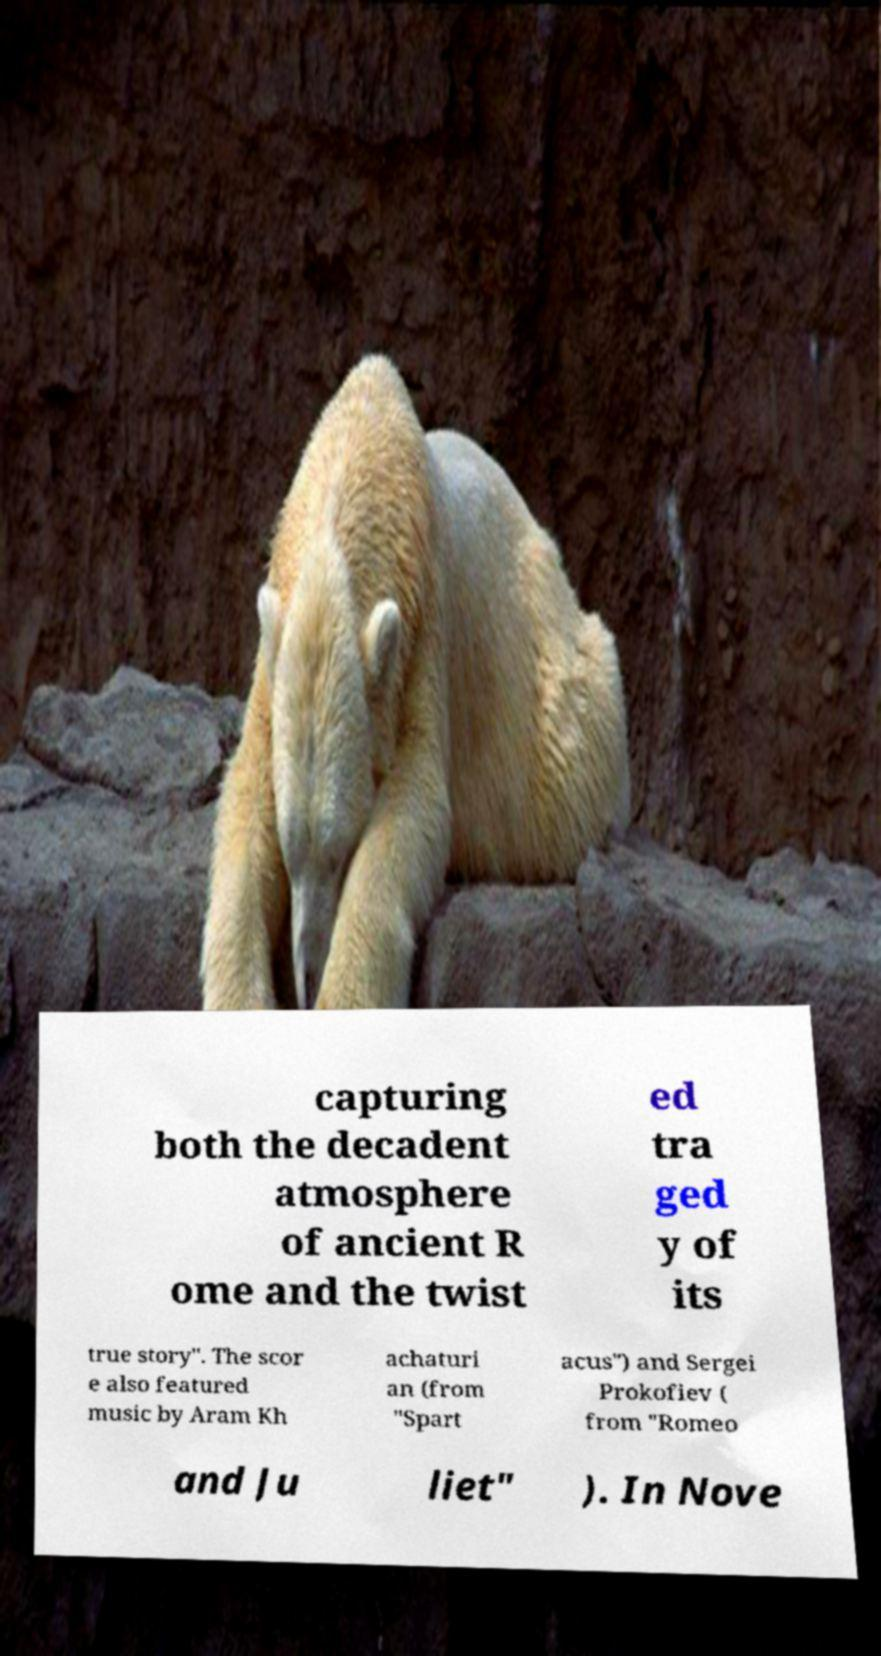What messages or text are displayed in this image? I need them in a readable, typed format. capturing both the decadent atmosphere of ancient R ome and the twist ed tra ged y of its true story". The scor e also featured music by Aram Kh achaturi an (from "Spart acus") and Sergei Prokofiev ( from "Romeo and Ju liet" ). In Nove 